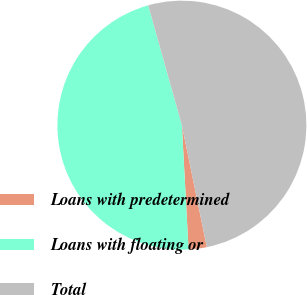Convert chart. <chart><loc_0><loc_0><loc_500><loc_500><pie_chart><fcel>Loans with predetermined<fcel>Loans with floating or<fcel>Total<nl><fcel>2.36%<fcel>46.5%<fcel>51.15%<nl></chart> 